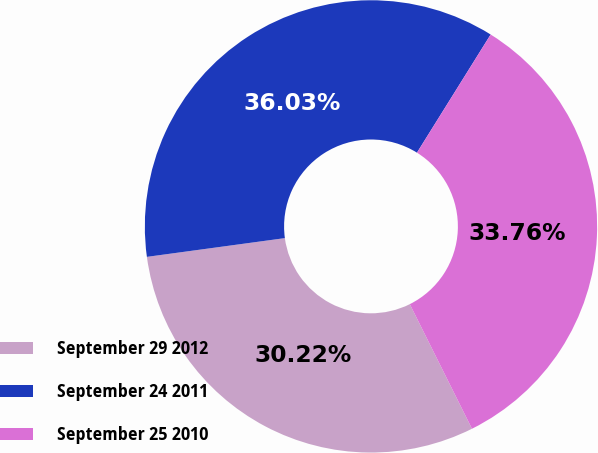Convert chart to OTSL. <chart><loc_0><loc_0><loc_500><loc_500><pie_chart><fcel>September 29 2012<fcel>September 24 2011<fcel>September 25 2010<nl><fcel>30.22%<fcel>36.03%<fcel>33.76%<nl></chart> 